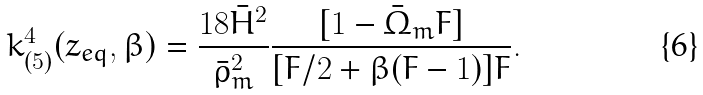Convert formula to latex. <formula><loc_0><loc_0><loc_500><loc_500>k _ { ( 5 ) } ^ { 4 } ( z _ { e q } , \beta ) = \frac { 1 8 { \bar { H } } ^ { 2 } } { { \bar { \rho } } _ { m } ^ { 2 } } \frac { [ 1 - { \bar { \Omega } } _ { m } F ] } { [ F / 2 + \beta ( F - 1 ) ] F } .</formula> 